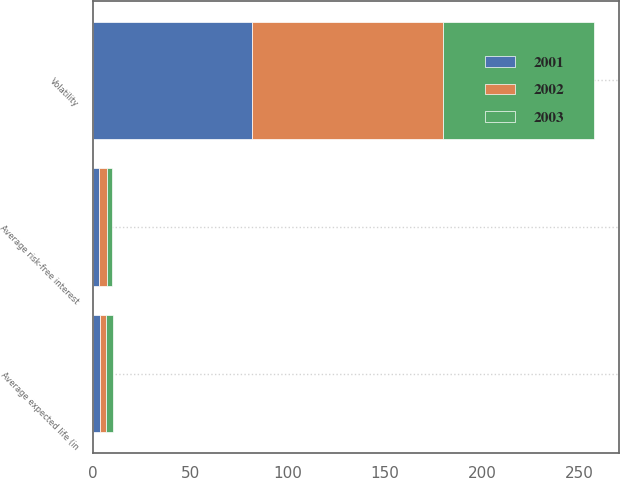Convert chart. <chart><loc_0><loc_0><loc_500><loc_500><stacked_bar_chart><ecel><fcel>Average risk-free interest<fcel>Average expected life (in<fcel>Volatility<nl><fcel>2003<fcel>2.5<fcel>3.3<fcel>77.7<nl><fcel>2001<fcel>3.1<fcel>3.3<fcel>81.8<nl><fcel>2002<fcel>4.1<fcel>3.3<fcel>98<nl></chart> 